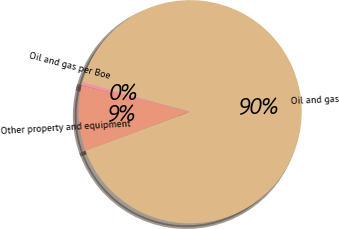<chart> <loc_0><loc_0><loc_500><loc_500><pie_chart><fcel>Oil and gas per Boe<fcel>Oil and gas<fcel>Other property and equipment<nl><fcel>0.45%<fcel>90.12%<fcel>9.42%<nl></chart> 